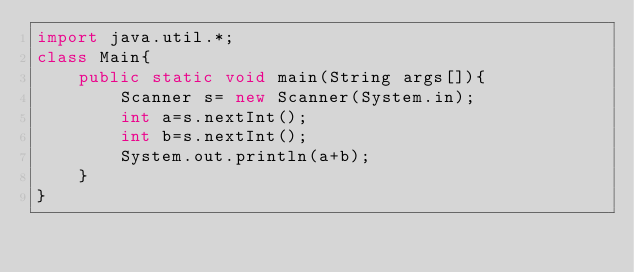Convert code to text. <code><loc_0><loc_0><loc_500><loc_500><_Java_>import java.util.*;
class Main{
	public static void main(String args[]){
    	Scanner s= new Scanner(System.in);
      	int a=s.nextInt();
      	int b=s.nextInt();
      	System.out.println(a+b);
    }
}</code> 